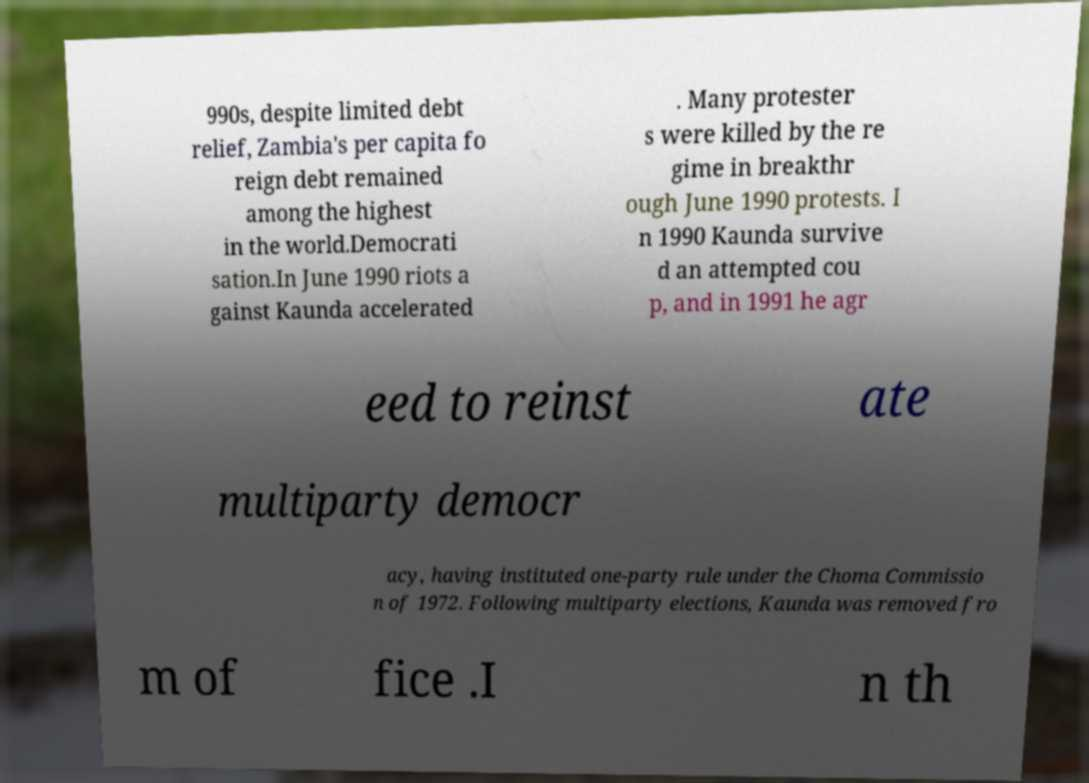What messages or text are displayed in this image? I need them in a readable, typed format. 990s, despite limited debt relief, Zambia's per capita fo reign debt remained among the highest in the world.Democrati sation.In June 1990 riots a gainst Kaunda accelerated . Many protester s were killed by the re gime in breakthr ough June 1990 protests. I n 1990 Kaunda survive d an attempted cou p, and in 1991 he agr eed to reinst ate multiparty democr acy, having instituted one-party rule under the Choma Commissio n of 1972. Following multiparty elections, Kaunda was removed fro m of fice .I n th 